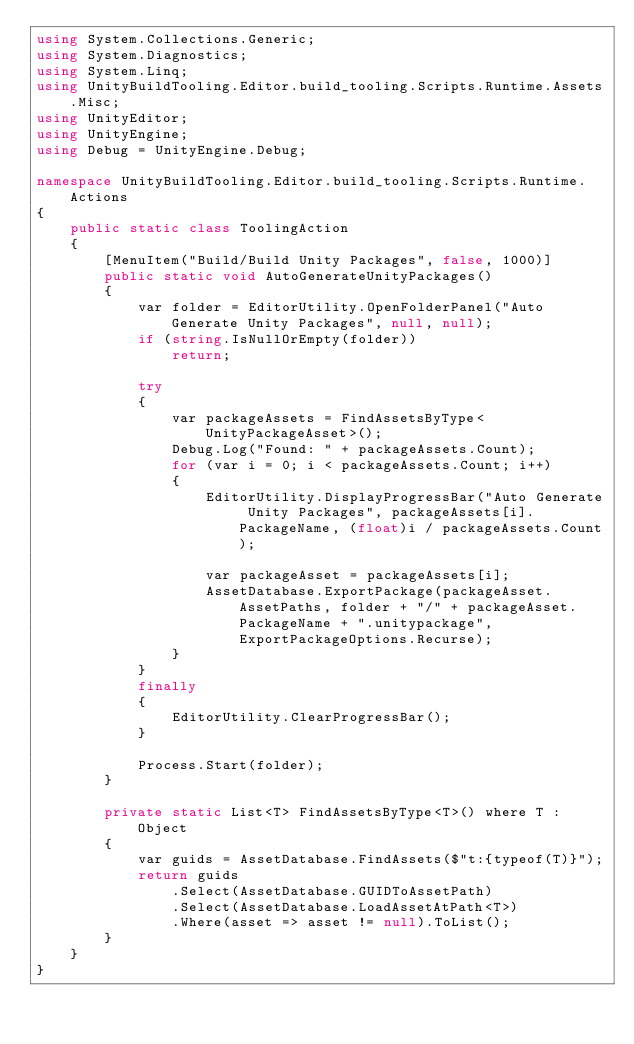<code> <loc_0><loc_0><loc_500><loc_500><_C#_>using System.Collections.Generic;
using System.Diagnostics;
using System.Linq;
using UnityBuildTooling.Editor.build_tooling.Scripts.Runtime.Assets.Misc;
using UnityEditor;
using UnityEngine;
using Debug = UnityEngine.Debug;

namespace UnityBuildTooling.Editor.build_tooling.Scripts.Runtime.Actions
{
    public static class ToolingAction
    {
        [MenuItem("Build/Build Unity Packages", false, 1000)]
        public static void AutoGenerateUnityPackages()
        {
            var folder = EditorUtility.OpenFolderPanel("Auto Generate Unity Packages", null, null);
            if (string.IsNullOrEmpty(folder))
                return;

            try
            {
                var packageAssets = FindAssetsByType<UnityPackageAsset>();
                Debug.Log("Found: " + packageAssets.Count);
                for (var i = 0; i < packageAssets.Count; i++)
                {
                    EditorUtility.DisplayProgressBar("Auto Generate Unity Packages", packageAssets[i].PackageName, (float)i / packageAssets.Count);
                
                    var packageAsset = packageAssets[i];
                    AssetDatabase.ExportPackage(packageAsset.AssetPaths, folder + "/" + packageAsset.PackageName + ".unitypackage", ExportPackageOptions.Recurse);
                }
            }
            finally
            {
                EditorUtility.ClearProgressBar();
            }

            Process.Start(folder);
        }
        
        private static List<T> FindAssetsByType<T>() where T : Object
        {
            var guids = AssetDatabase.FindAssets($"t:{typeof(T)}");
            return guids
                .Select(AssetDatabase.GUIDToAssetPath)
                .Select(AssetDatabase.LoadAssetAtPath<T>)
                .Where(asset => asset != null).ToList();
        }
    }
}</code> 